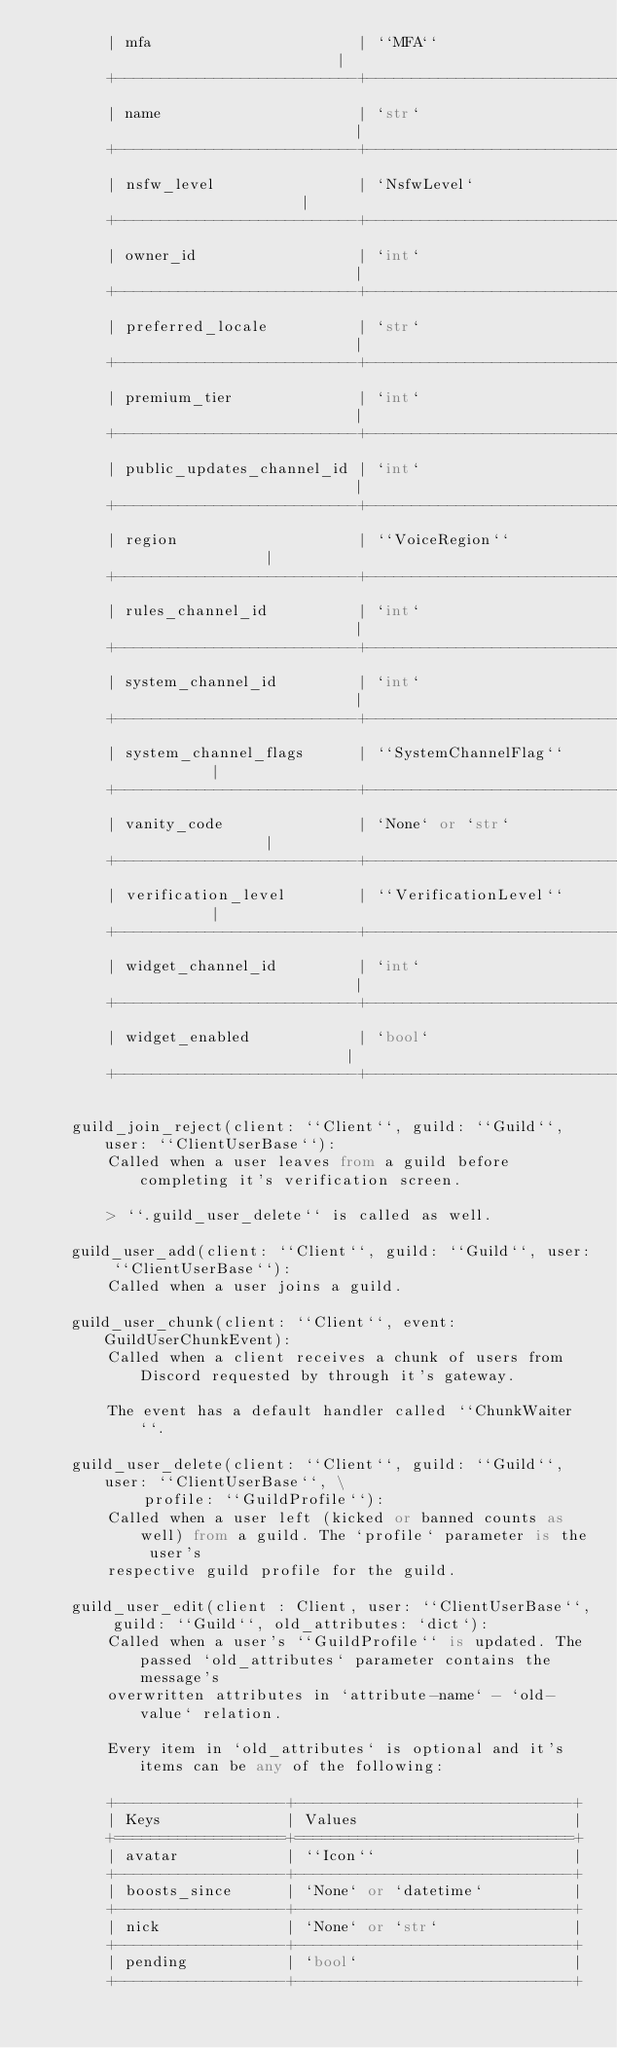Convert code to text. <code><loc_0><loc_0><loc_500><loc_500><_Python_>        | mfa                       | ``MFA``                       |
        +---------------------------+-------------------------------+
        | name                      | `str`                         |
        +---------------------------+-------------------------------+
        | nsfw_level                | `NsfwLevel`                   |
        +---------------------------+-------------------------------+
        | owner_id                  | `int`                         |
        +---------------------------+-------------------------------+
        | preferred_locale          | `str`                         |
        +---------------------------+-------------------------------+
        | premium_tier              | `int`                         |
        +---------------------------+-------------------------------+
        | public_updates_channel_id | `int`                         |
        +---------------------------+-------------------------------+
        | region                    | ``VoiceRegion``               |
        +---------------------------+-------------------------------+
        | rules_channel_id          | `int`                         |
        +---------------------------+-------------------------------+
        | system_channel_id         | `int`                         |
        +---------------------------+-------------------------------+
        | system_channel_flags      | ``SystemChannelFlag``         |
        +---------------------------+-------------------------------+
        | vanity_code               | `None` or `str`               |
        +---------------------------+-------------------------------+
        | verification_level        | ``VerificationLevel``         |
        +---------------------------+-------------------------------+
        | widget_channel_id         | `int`                         |
        +---------------------------+-------------------------------+
        | widget_enabled            | `bool`                        |
        +---------------------------+-------------------------------+
    
    guild_join_reject(client: ``Client``, guild: ``Guild``, user: ``ClientUserBase``):
        Called when a user leaves from a guild before completing it's verification screen.
        
        > ``.guild_user_delete`` is called as well.
    
    guild_user_add(client: ``Client``, guild: ``Guild``, user: ``ClientUserBase``):
        Called when a user joins a guild.
    
    guild_user_chunk(client: ``Client``, event: GuildUserChunkEvent):
        Called when a client receives a chunk of users from Discord requested by through it's gateway.
        
        The event has a default handler called ``ChunkWaiter``.
    
    guild_user_delete(client: ``Client``, guild: ``Guild``, user: ``ClientUserBase``, \
            profile: ``GuildProfile``):
        Called when a user left (kicked or banned counts as well) from a guild. The `profile` parameter is the user's
        respective guild profile for the guild.
    
    guild_user_edit(client : Client, user: ``ClientUserBase``, guild: ``Guild``, old_attributes: `dict`):
        Called when a user's ``GuildProfile`` is updated. The passed `old_attributes` parameter contains the message's
        overwritten attributes in `attribute-name` - `old-value` relation.
        
        Every item in `old_attributes` is optional and it's items can be any of the following:
        
        +-------------------+-------------------------------+
        | Keys              | Values                        |
        +===================+===============================+
        | avatar            | ``Icon``                      |
        +-------------------+-------------------------------+
        | boosts_since      | `None` or `datetime`          |
        +-------------------+-------------------------------+
        | nick              | `None` or `str`               |
        +-------------------+-------------------------------+
        | pending           | `bool`                        |
        +-------------------+-------------------------------+</code> 